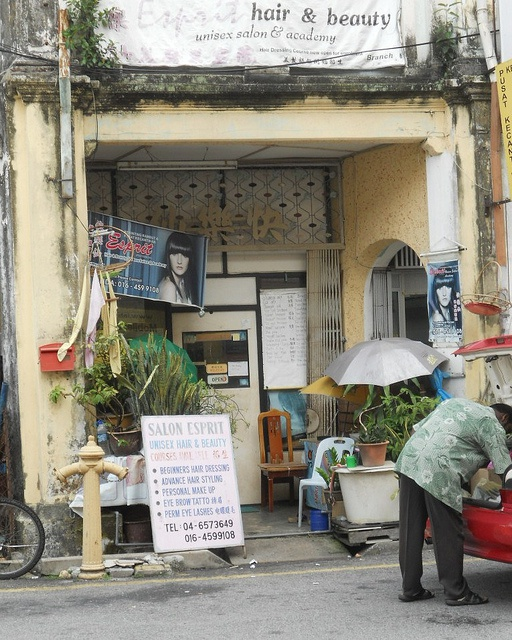Describe the objects in this image and their specific colors. I can see people in gray, black, darkgray, and lightgray tones, potted plant in gray, black, darkgreen, and olive tones, potted plant in gray, darkgreen, black, and green tones, umbrella in gray, lightgray, and darkgray tones, and fire hydrant in gray, tan, and beige tones in this image. 